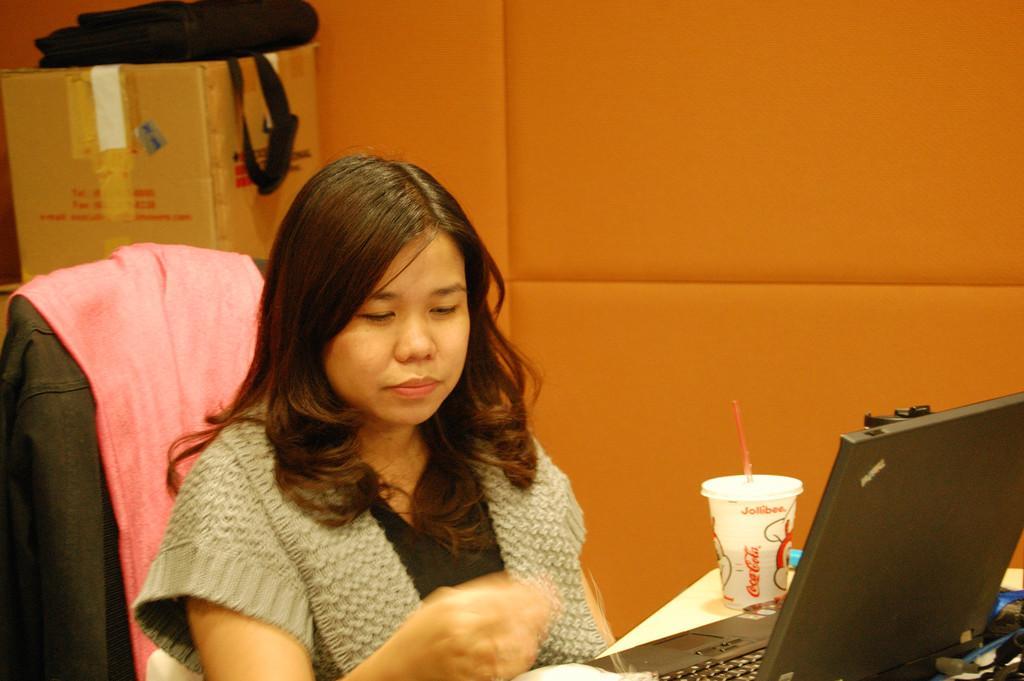In one or two sentences, can you explain what this image depicts? In this image we can see a woman sitting on the chair. There are laptop and cup on the table. In the background of the image we can see a cardboard box, a bag and a wall. 